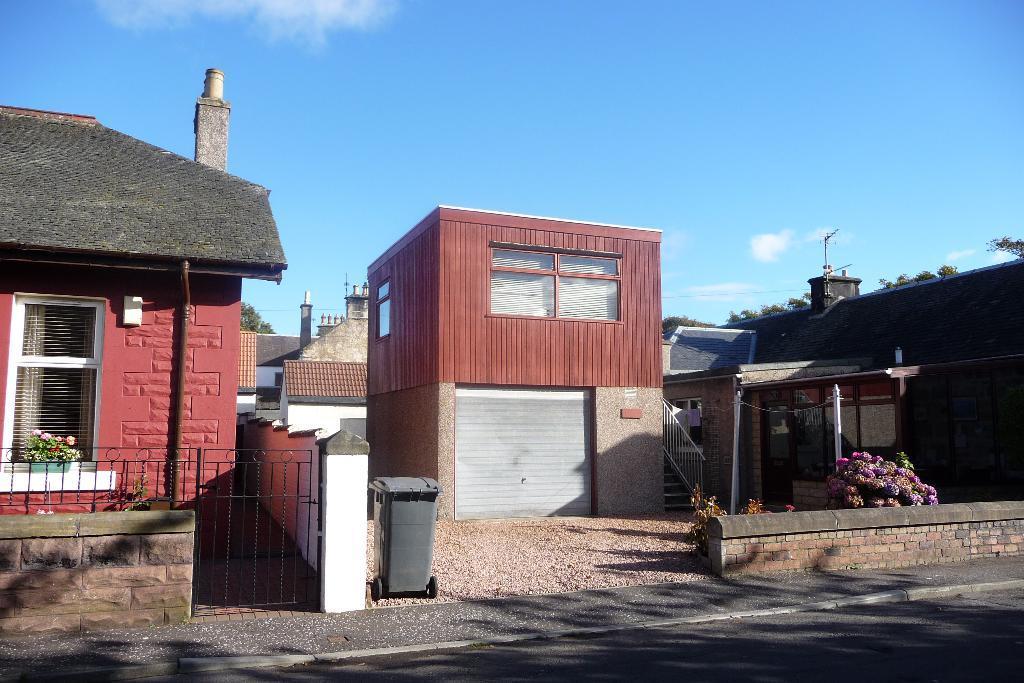Please provide a concise description of this image. In this image we can see buildings, houseplants, iron grills, staircase, railing, poles, trash bin, bushes, trees, chimneys, antennas and sky with clouds. 